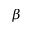Convert formula to latex. <formula><loc_0><loc_0><loc_500><loc_500>\beta</formula> 